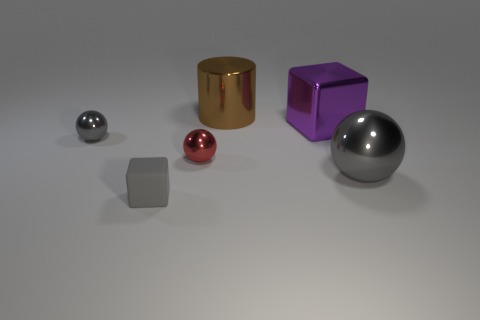What number of cubes are either tiny things or small gray metal things? There is one small cube in the image, which is a small gray metal thing. No tiny cubes can be seen, so the total number of cubes that are tiny things or small gray metal things is one. 